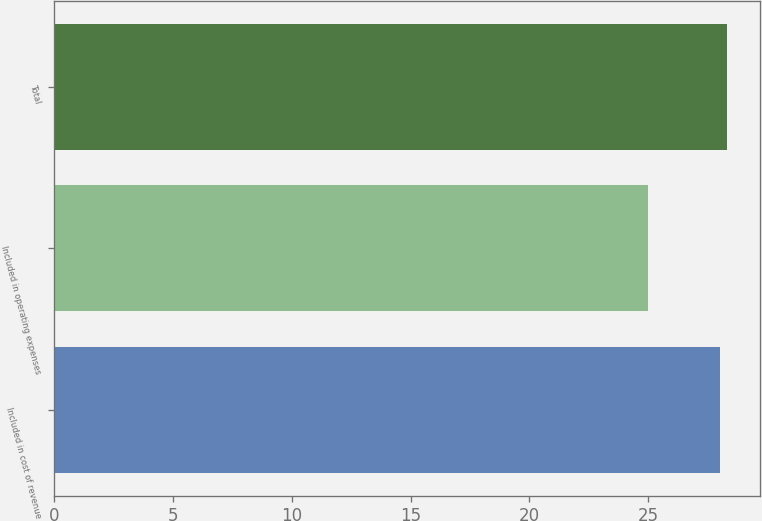<chart> <loc_0><loc_0><loc_500><loc_500><bar_chart><fcel>Included in cost of revenue<fcel>Included in operating expenses<fcel>Total<nl><fcel>28<fcel>25<fcel>28.3<nl></chart> 